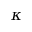Convert formula to latex. <formula><loc_0><loc_0><loc_500><loc_500>\kappa</formula> 